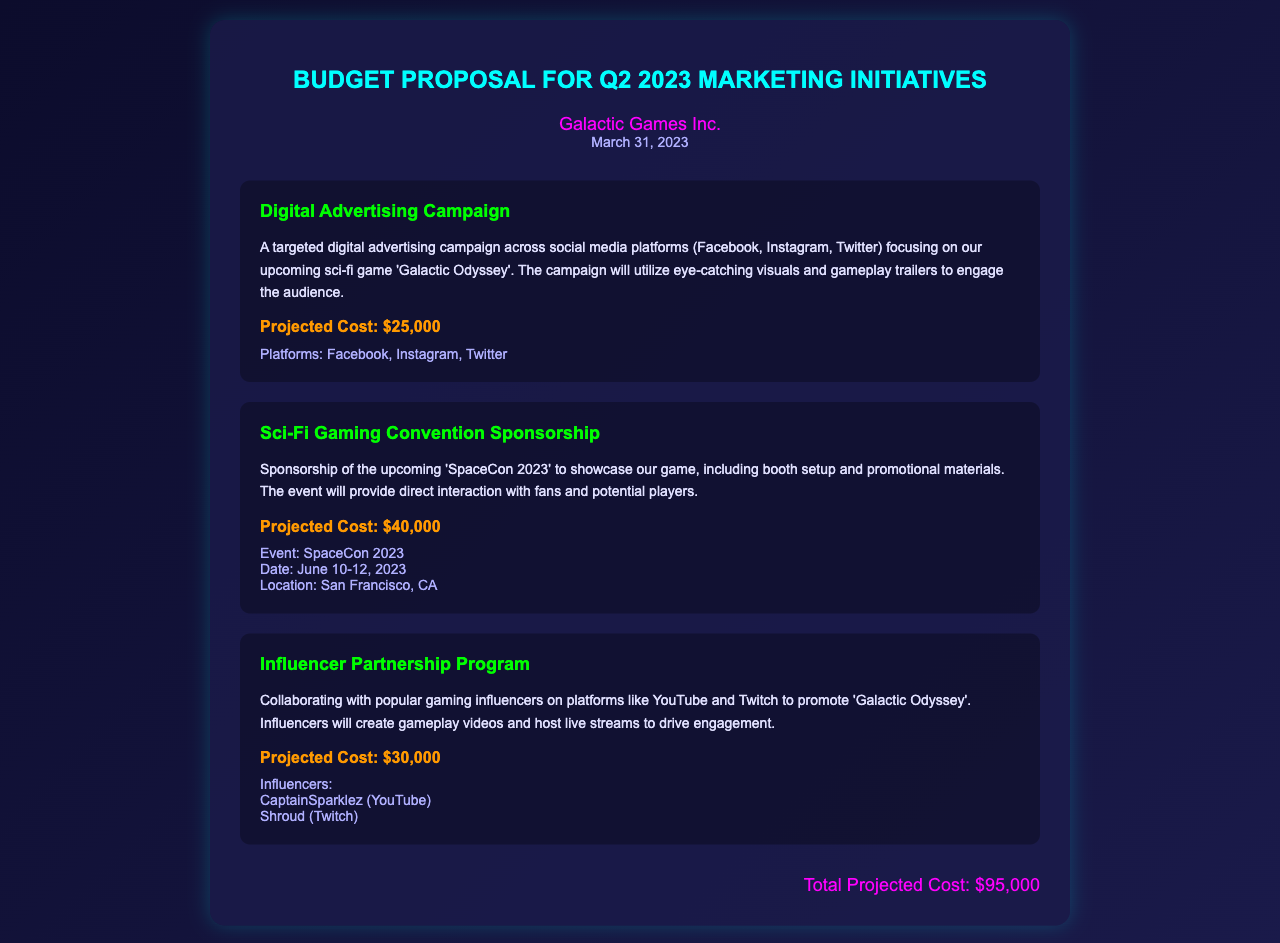What is the title of the proposal? The title of the proposal is found in the document header, which states it is a Budget Proposal for Q2 2023 Marketing Initiatives.
Answer: Budget Proposal for Q2 2023 Marketing Initiatives What is the projected cost of the Digital Advertising Campaign? The projected cost of the Digital Advertising Campaign is explicitly stated in the initiative section.
Answer: $25,000 When is the SpaceCon 2023 event taking place? The dates for the SpaceCon 2023 event are provided in the event details of the sponsorship section.
Answer: June 10-12, 2023 Who are the influencers mentioned in the Influencer Partnership Program? The influencers are specifically listed in the influencer program section of the document.
Answer: CaptainSparklez, Shroud What is the total projected cost for all initiatives? The total projected cost is calculated and listed at the end of the document.
Answer: $95,000 What location will SpaceCon 2023 be held? The location for SpaceCon 2023 is provided in the event details under the sponsorship initiative.
Answer: San Francisco, CA What is the main theme of the gaming company’s upcoming title? The theme can be derived from the context of the marketing initiatives, specifically mentioned in the Digital Advertising Campaign.
Answer: Sci-fi What is the purpose of the influencer partnership program? The purpose is mentioned in the description of the influencer partnership program initiative.
Answer: Promote 'Galactic Odyssey' What color is the title of the proposal? The color of the title can be found in the document’s style or can be inferred from the displayed content.
Answer: Cyan 